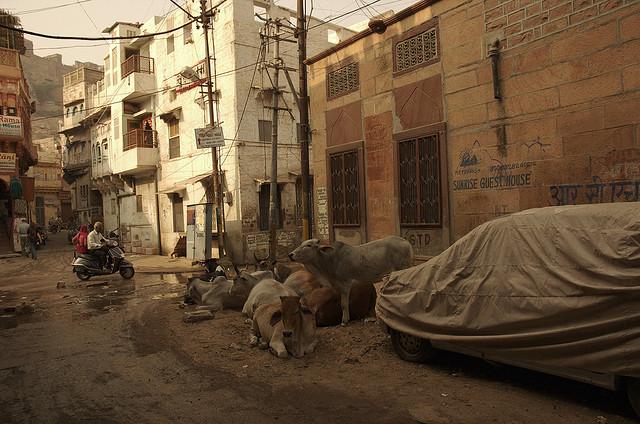Are the animal comfortable?
Be succinct. No. Is this a busy street?
Quick response, please. No. Will a lot of the world look like this after a smart robot takeover?
Answer briefly. Yes. What animals are shown?
Quick response, please. Cows. Are the doors wooden?
Concise answer only. Yes. Is this area run down?
Quick response, please. Yes. What is in the picture?
Short answer required. Cows. What is the sex of these animal?
Be succinct. Male. Is this daytime?
Give a very brief answer. Yes. What event happened here?
Write a very short answer. War. What is pulling the carriages?
Short answer required. Nothing. 